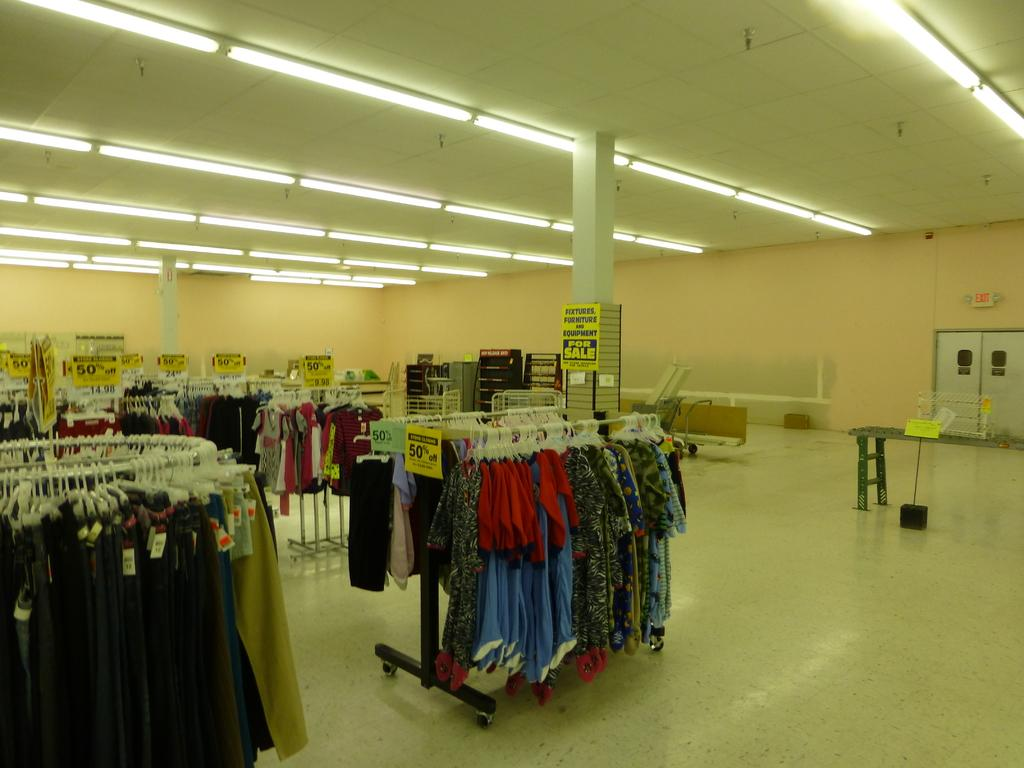What type of establishment is depicted in the image? The image shows the inner view of a store. What items can be seen hanging in the store? There are clothes on hangers in the image. How can customers determine the prices of the items in the store? Price boards are visible in the image. What type of lighting is present in the store? Lights are present on the ceiling in the image. How many feet are visible in the image? There are no feet visible in the image; it shows the inner view of a store with clothes on hangers, price boards, and lights on the ceiling. 